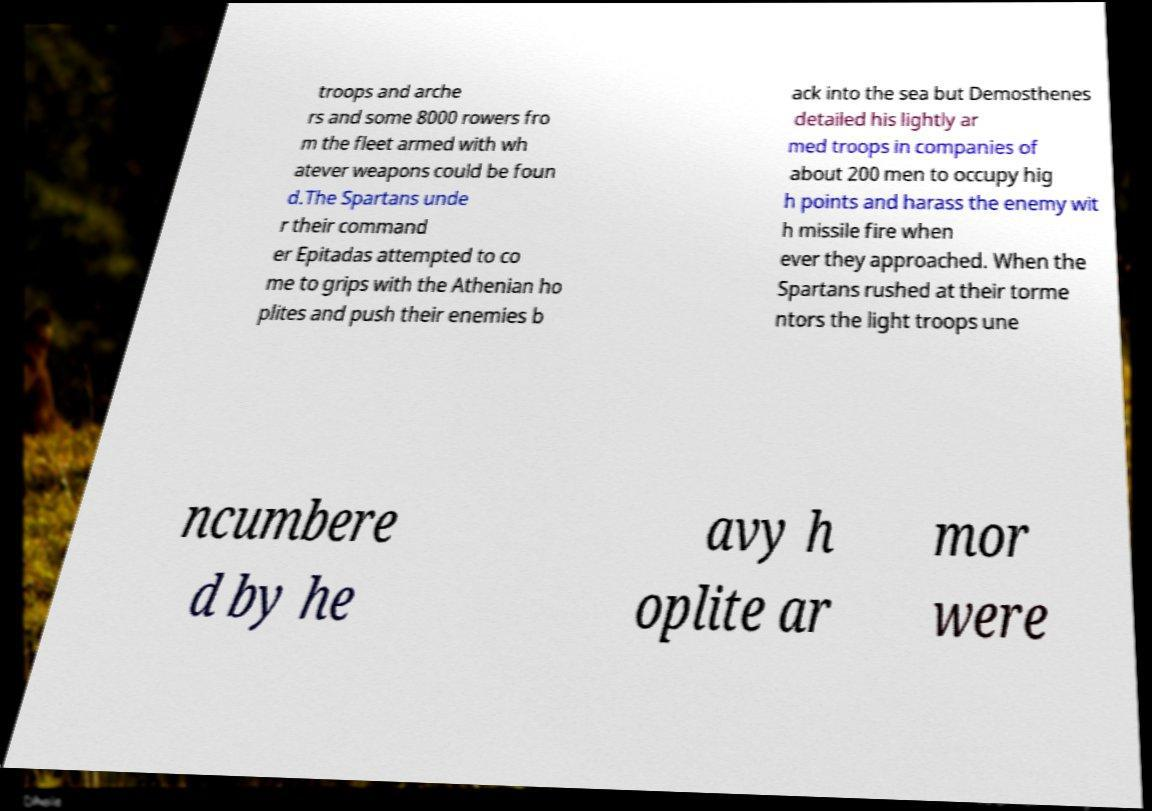Can you read and provide the text displayed in the image?This photo seems to have some interesting text. Can you extract and type it out for me? troops and arche rs and some 8000 rowers fro m the fleet armed with wh atever weapons could be foun d.The Spartans unde r their command er Epitadas attempted to co me to grips with the Athenian ho plites and push their enemies b ack into the sea but Demosthenes detailed his lightly ar med troops in companies of about 200 men to occupy hig h points and harass the enemy wit h missile fire when ever they approached. When the Spartans rushed at their torme ntors the light troops une ncumbere d by he avy h oplite ar mor were 